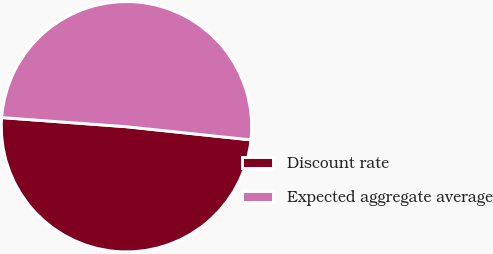Convert chart. <chart><loc_0><loc_0><loc_500><loc_500><pie_chart><fcel>Discount rate<fcel>Expected aggregate average<nl><fcel>49.49%<fcel>50.51%<nl></chart> 